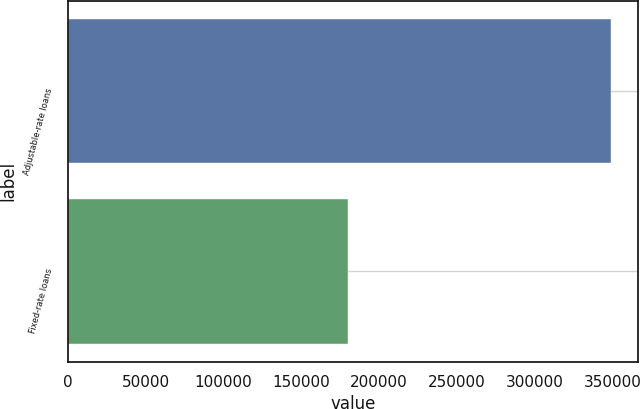Convert chart to OTSL. <chart><loc_0><loc_0><loc_500><loc_500><bar_chart><fcel>Adjustable-rate loans<fcel>Fixed-rate loans<nl><fcel>349035<fcel>180159<nl></chart> 